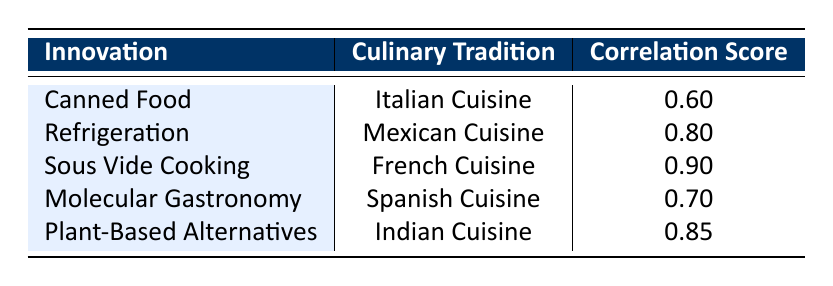What culinary tradition is associated with the impact of canned food? According to the table, canned food is correlated with Italian Cuisine.
Answer: Italian Cuisine Which innovation has the highest correlation score with a culinary tradition? The table shows that Sous Vide Cooking has the highest correlation score of 0.90 with French Cuisine.
Answer: 0.90 Is the correlation score between refrigeration and Mexican cuisine above 0.7? The table indicates that refrigeration has a correlation score of 0.80 with Mexican Cuisine, which is above 0.7.
Answer: Yes What is the average correlation score for the innovations listed in the table? The scores are 0.60 (Canned Food), 0.80 (Refrigeration), 0.90 (Sous Vide Cooking), 0.70 (Molecular Gastronomy), and 0.85 (Plant-Based Alternatives). The total is 0.60 + 0.80 + 0.90 + 0.70 + 0.85 = 3.85, and there are 5 innovations, so the average is 3.85 / 5 = 0.77.
Answer: 0.77 What correlation score is associated with Plant-Based Alternatives? The table lists the correlation score for Plant-Based Alternatives as 0.85 with Indian Cuisine.
Answer: 0.85 